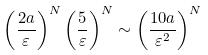<formula> <loc_0><loc_0><loc_500><loc_500>\left ( \frac { 2 a } { \varepsilon } \right ) ^ { N } \left ( \frac { 5 } { \varepsilon } \right ) ^ { N } \sim \left ( \frac { 1 0 a } { \varepsilon ^ { 2 } } \right ) ^ { N }</formula> 